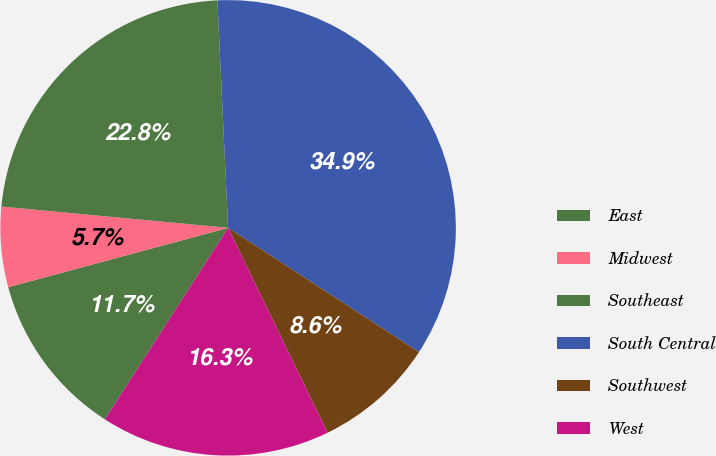<chart> <loc_0><loc_0><loc_500><loc_500><pie_chart><fcel>East<fcel>Midwest<fcel>Southeast<fcel>South Central<fcel>Southwest<fcel>West<nl><fcel>11.7%<fcel>5.69%<fcel>22.76%<fcel>34.94%<fcel>8.62%<fcel>16.3%<nl></chart> 